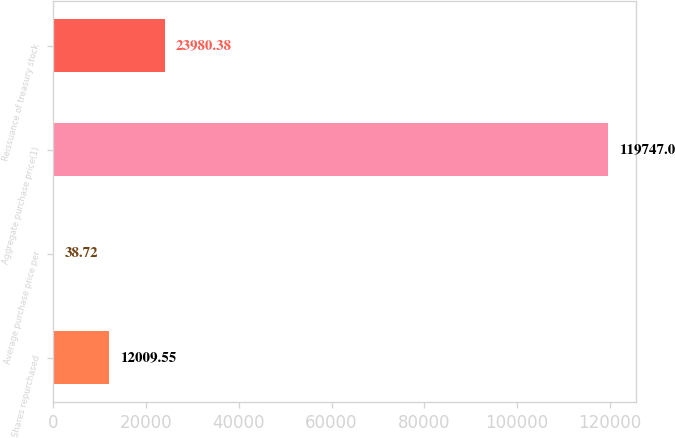Convert chart. <chart><loc_0><loc_0><loc_500><loc_500><bar_chart><fcel>Shares repurchased<fcel>Average purchase price per<fcel>Aggregate purchase price(1)<fcel>Reissuance of treasury stock<nl><fcel>12009.5<fcel>38.72<fcel>119747<fcel>23980.4<nl></chart> 